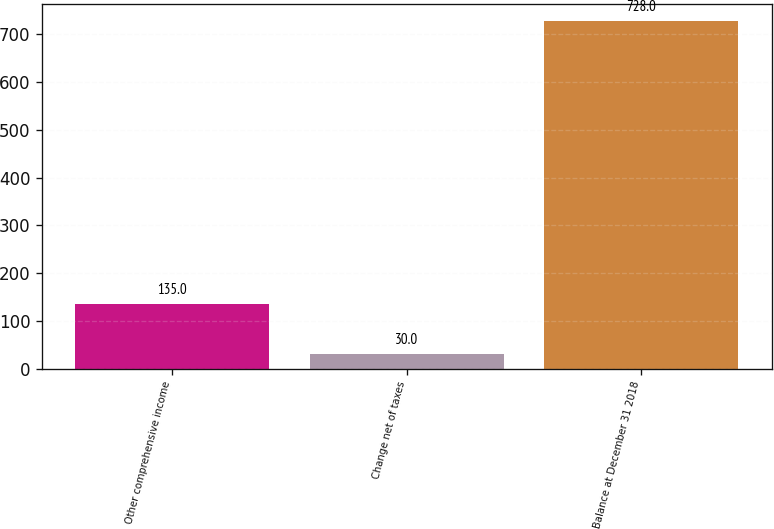Convert chart. <chart><loc_0><loc_0><loc_500><loc_500><bar_chart><fcel>Other comprehensive income<fcel>Change net of taxes<fcel>Balance at December 31 2018<nl><fcel>135<fcel>30<fcel>728<nl></chart> 